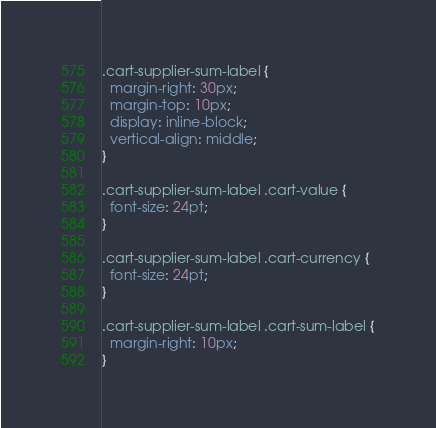<code> <loc_0><loc_0><loc_500><loc_500><_CSS_>.cart-supplier-sum-label {
  margin-right: 30px;
  margin-top: 10px;
  display: inline-block;
  vertical-align: middle;
}

.cart-supplier-sum-label .cart-value {
  font-size: 24pt;
}

.cart-supplier-sum-label .cart-currency {
  font-size: 24pt;
}

.cart-supplier-sum-label .cart-sum-label {
  margin-right: 10px;
}
</code> 